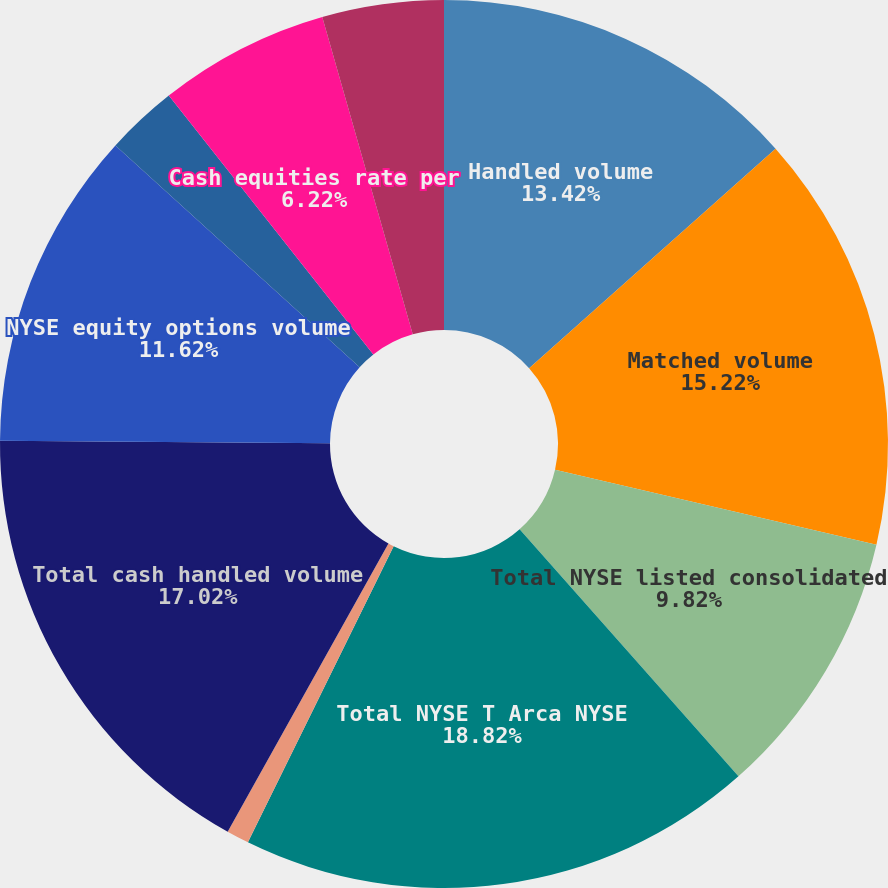Convert chart to OTSL. <chart><loc_0><loc_0><loc_500><loc_500><pie_chart><fcel>Handled volume<fcel>Matched volume<fcel>Total NYSE listed consolidated<fcel>Total NYSE T Arca NYSE<fcel>Total Nasdaq listed<fcel>Total cash handled volume<fcel>NYSE equity options volume<fcel>Total equity options volume T<fcel>Cash equities rate per<fcel>Equity options rate per<nl><fcel>13.42%<fcel>15.22%<fcel>9.82%<fcel>18.82%<fcel>0.82%<fcel>17.02%<fcel>11.62%<fcel>2.62%<fcel>6.22%<fcel>4.42%<nl></chart> 